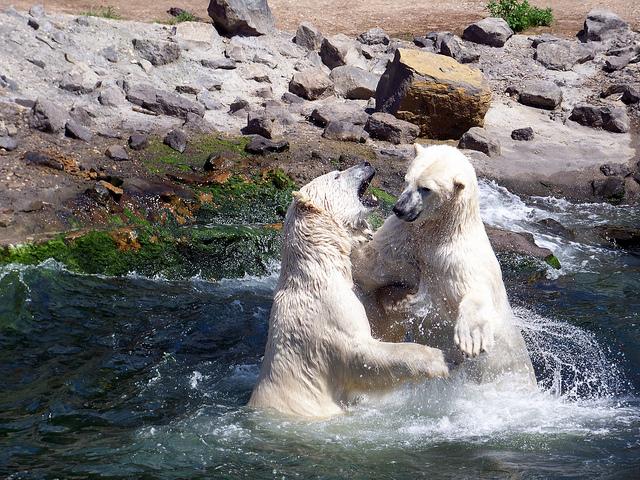Could this be a contained environment?
Concise answer only. Yes. Are the bears happy?
Short answer required. Yes. Are the bears swimming?
Short answer required. No. 